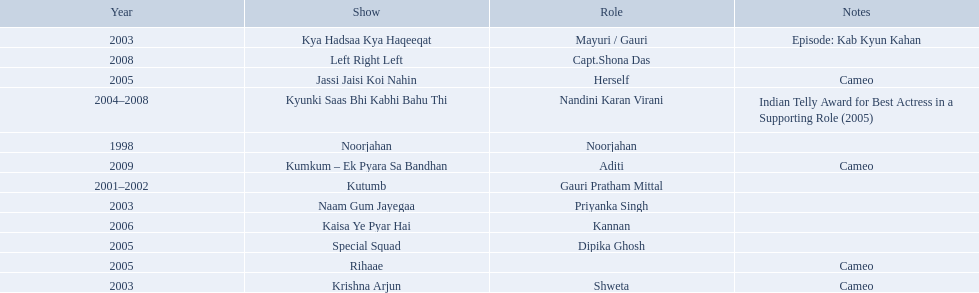What are all of the shows? Noorjahan, Kutumb, Krishna Arjun, Naam Gum Jayegaa, Kya Hadsaa Kya Haqeeqat, Kyunki Saas Bhi Kabhi Bahu Thi, Rihaae, Jassi Jaisi Koi Nahin, Special Squad, Kaisa Ye Pyar Hai, Left Right Left, Kumkum – Ek Pyara Sa Bandhan. When were they in production? 1998, 2001–2002, 2003, 2003, 2003, 2004–2008, 2005, 2005, 2005, 2006, 2008, 2009. And which show was he on for the longest time? Kyunki Saas Bhi Kabhi Bahu Thi. Parse the full table in json format. {'header': ['Year', 'Show', 'Role', 'Notes'], 'rows': [['2003', 'Kya Hadsaa Kya Haqeeqat', 'Mayuri / Gauri', 'Episode: Kab Kyun Kahan'], ['2008', 'Left Right Left', 'Capt.Shona Das', ''], ['2005', 'Jassi Jaisi Koi Nahin', 'Herself', 'Cameo'], ['2004–2008', 'Kyunki Saas Bhi Kabhi Bahu Thi', 'Nandini Karan Virani', 'Indian Telly Award for Best Actress in a Supporting Role (2005)'], ['1998', 'Noorjahan', 'Noorjahan', ''], ['2009', 'Kumkum – Ek Pyara Sa Bandhan', 'Aditi', 'Cameo'], ['2001–2002', 'Kutumb', 'Gauri Pratham Mittal', ''], ['2003', 'Naam Gum Jayegaa', 'Priyanka Singh', ''], ['2006', 'Kaisa Ye Pyar Hai', 'Kannan', ''], ['2005', 'Special Squad', 'Dipika Ghosh', ''], ['2005', 'Rihaae', '', 'Cameo'], ['2003', 'Krishna Arjun', 'Shweta', 'Cameo']]} 